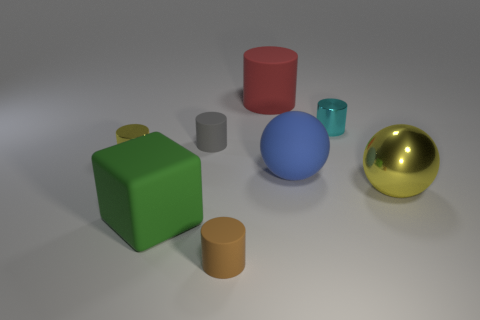Subtract 1 cylinders. How many cylinders are left? 4 Add 1 small rubber things. How many objects exist? 9 Subtract all cubes. How many objects are left? 7 Add 2 cyan shiny cylinders. How many cyan shiny cylinders are left? 3 Add 4 balls. How many balls exist? 6 Subtract 0 cyan blocks. How many objects are left? 8 Subtract all gray matte things. Subtract all metal things. How many objects are left? 4 